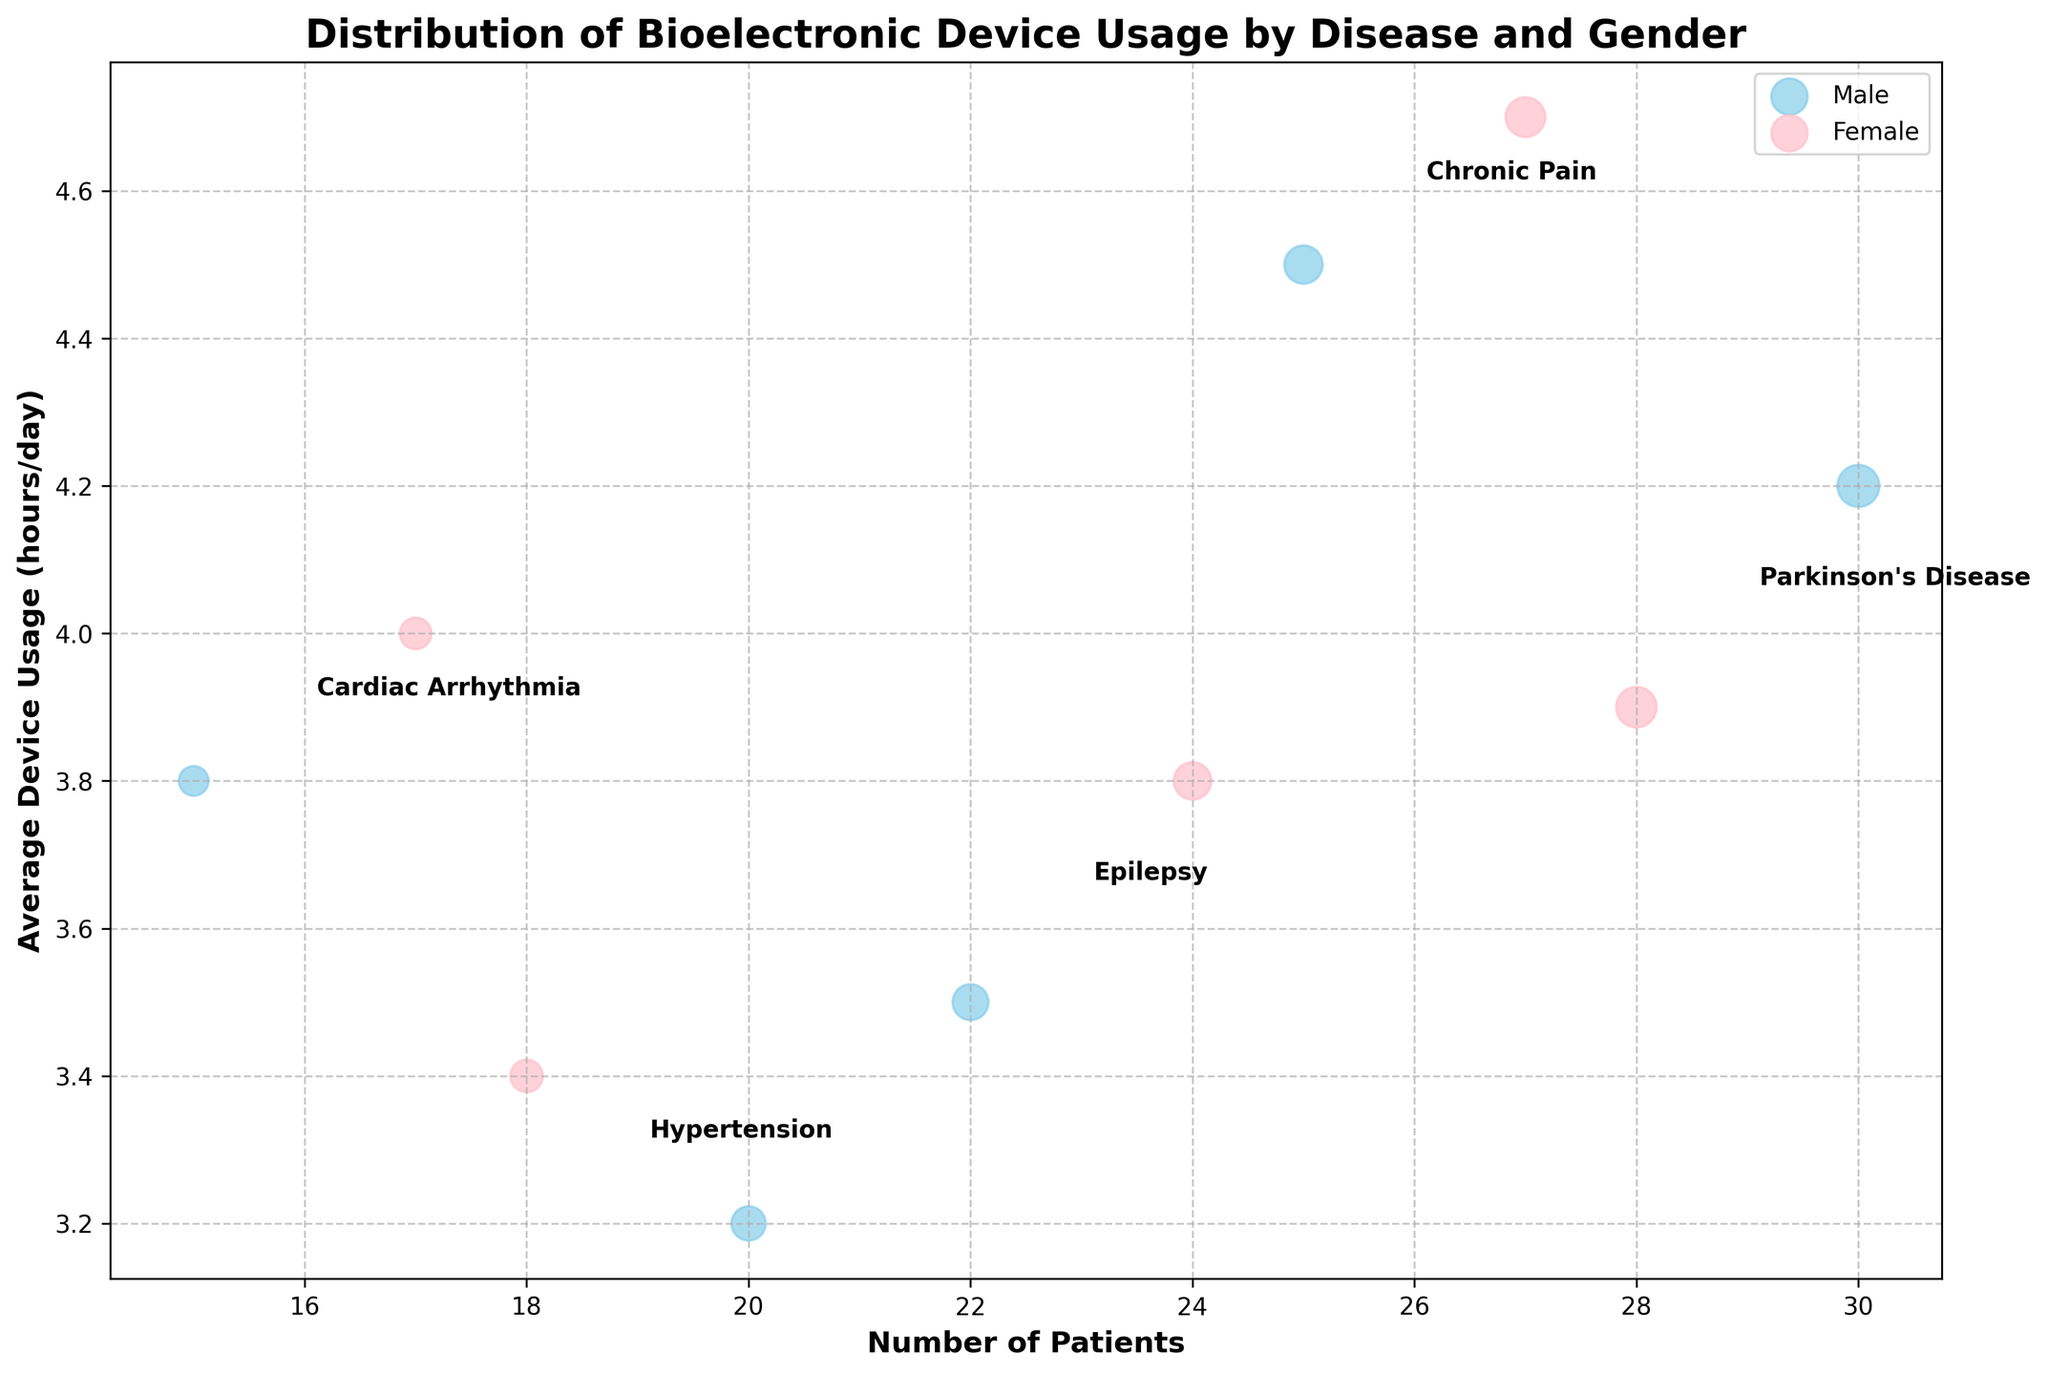What is the title of the chart? The title can be found at the top of the chart, indicating the overall theme and context of the visualization.
Answer: Distribution of Bioelectronic Device Usage by Disease and Gender Which gender has the highest average device usage for Chronic Pain? Look for the "Chronic Pain" label and compare the positions of the male and female bubbles on the y-axis, which represents average device usage.
Answer: Female How many disease types are represented in the chart? Count the distinct labels of disease types that are annotated in the plot.
Answer: 5 Which disease type has the least number of male patients? Identify the disease label with the smallest bubble size on the x-axis among the male gender bubbles.
Answer: Cardiac Arrhythmia What is the average device usage for males with Parkinson's Disease? Locate the bubble for males with Parkinson's Disease and read the y-axis value corresponding to it.
Answer: 4.2 What is the difference in the number of patients with Epilepsy between males and females? Find the x-axis values for males and females with Epilepsy, then calculate the absolute difference between these two numbers.
Answer: 2 Which disease type shows the highest average device usage for females? Compare the y-axis positions of all female bubbles across different disease types and identify the highest point.
Answer: Chronic Pain How does the average device usage for males with Hypertension compare to females with Epilepsy? Find the y-axis values for males with Hypertension and females with Epilepsy, then compare those two values to determine which is higher.
Answer: Females with Epilepsy use the device more What is the total number of female patients with bioelectronic devices? Sum the x-axis values of all bubbles corresponding to females, across different disease types.
Answer: 114 Which gender has more patients using bioelectronic devices for Hypertension? Look at the x-axis values for the population of both males and females within the Hypertension label and compare them.
Answer: Male 